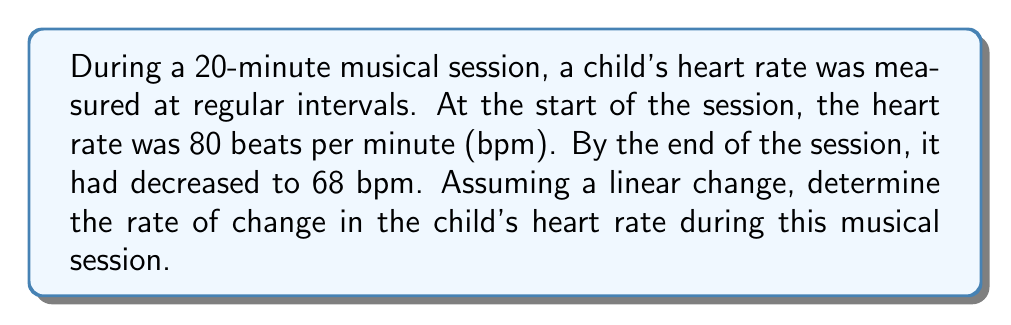Teach me how to tackle this problem. To find the rate of change, we need to calculate the slope of the line representing the change in heart rate over time. The formula for slope is:

$$m = \frac{y_2 - y_1}{x_2 - x_1}$$

Where:
$m$ = rate of change (slope)
$y_2$ = final heart rate
$y_1$ = initial heart rate
$x_2$ = final time
$x_1$ = initial time

Given:
- Initial heart rate: 80 bpm
- Final heart rate: 68 bpm
- Time duration: 20 minutes

Step 1: Plug the values into the slope formula:
$$m = \frac{68 \text{ bpm} - 80 \text{ bpm}}{20 \text{ min} - 0 \text{ min}}$$

Step 2: Simplify the numerator and denominator:
$$m = \frac{-12 \text{ bpm}}{20 \text{ min}}$$

Step 3: Divide to get the rate of change:
$$m = -0.6 \text{ bpm/min}$$

The negative value indicates a decrease in heart rate over time.
Answer: $-0.6 \text{ bpm/min}$ 